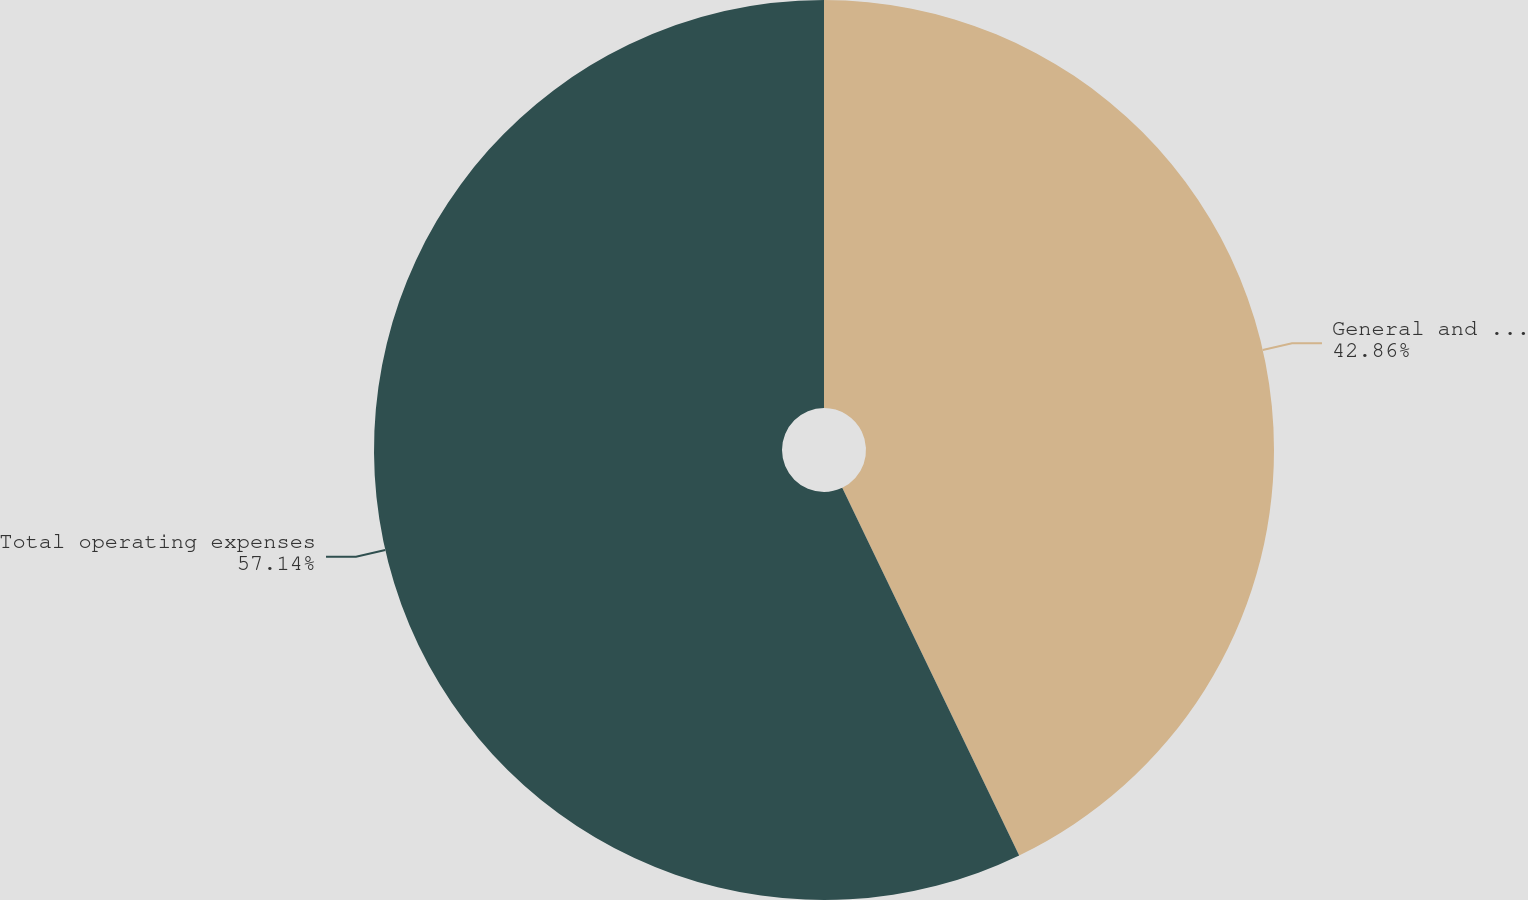<chart> <loc_0><loc_0><loc_500><loc_500><pie_chart><fcel>General and administrative<fcel>Total operating expenses<nl><fcel>42.86%<fcel>57.14%<nl></chart> 